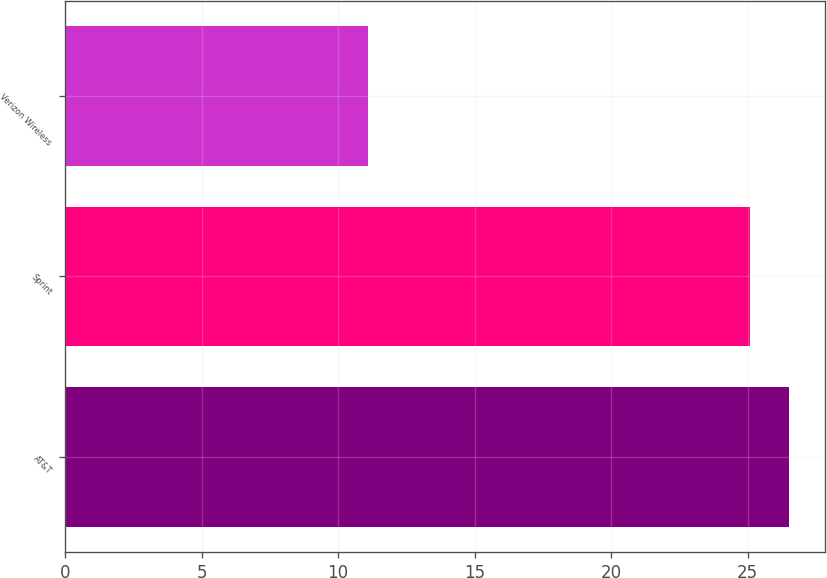Convert chart. <chart><loc_0><loc_0><loc_500><loc_500><bar_chart><fcel>AT&T<fcel>Sprint<fcel>Verizon Wireless<nl><fcel>26.52<fcel>25.1<fcel>11.1<nl></chart> 